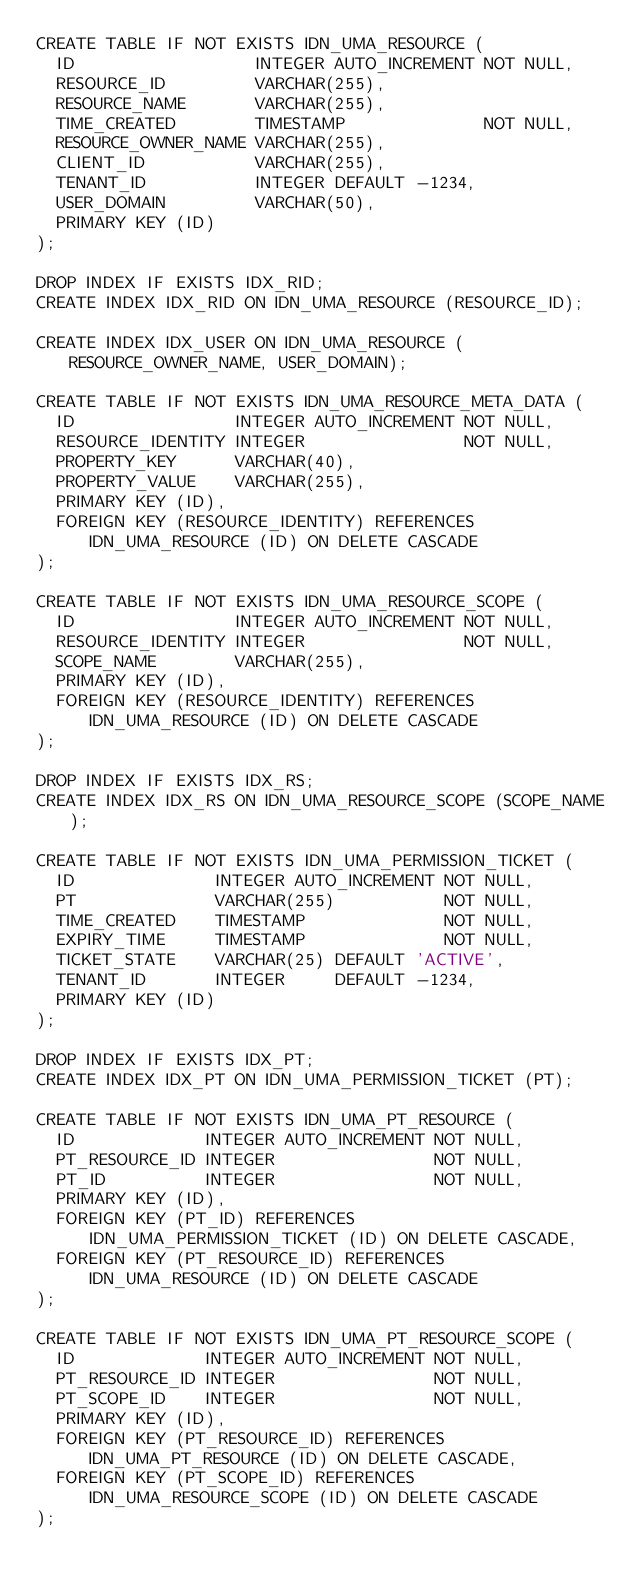<code> <loc_0><loc_0><loc_500><loc_500><_SQL_>CREATE TABLE IF NOT EXISTS IDN_UMA_RESOURCE (
  ID                  INTEGER AUTO_INCREMENT NOT NULL,
  RESOURCE_ID         VARCHAR(255),
  RESOURCE_NAME       VARCHAR(255),
  TIME_CREATED        TIMESTAMP              NOT NULL,
  RESOURCE_OWNER_NAME VARCHAR(255),
  CLIENT_ID           VARCHAR(255),
  TENANT_ID           INTEGER DEFAULT -1234,
  USER_DOMAIN         VARCHAR(50),
  PRIMARY KEY (ID)
);

DROP INDEX IF EXISTS IDX_RID;
CREATE INDEX IDX_RID ON IDN_UMA_RESOURCE (RESOURCE_ID);

CREATE INDEX IDX_USER ON IDN_UMA_RESOURCE (RESOURCE_OWNER_NAME, USER_DOMAIN);

CREATE TABLE IF NOT EXISTS IDN_UMA_RESOURCE_META_DATA (
  ID                INTEGER AUTO_INCREMENT NOT NULL,
  RESOURCE_IDENTITY INTEGER                NOT NULL,
  PROPERTY_KEY      VARCHAR(40),
  PROPERTY_VALUE    VARCHAR(255),
  PRIMARY KEY (ID),
  FOREIGN KEY (RESOURCE_IDENTITY) REFERENCES IDN_UMA_RESOURCE (ID) ON DELETE CASCADE
);

CREATE TABLE IF NOT EXISTS IDN_UMA_RESOURCE_SCOPE (
  ID                INTEGER AUTO_INCREMENT NOT NULL,
  RESOURCE_IDENTITY INTEGER                NOT NULL,
  SCOPE_NAME        VARCHAR(255),
  PRIMARY KEY (ID),
  FOREIGN KEY (RESOURCE_IDENTITY) REFERENCES IDN_UMA_RESOURCE (ID) ON DELETE CASCADE
);

DROP INDEX IF EXISTS IDX_RS;
CREATE INDEX IDX_RS ON IDN_UMA_RESOURCE_SCOPE (SCOPE_NAME);

CREATE TABLE IF NOT EXISTS IDN_UMA_PERMISSION_TICKET (
  ID              INTEGER AUTO_INCREMENT NOT NULL,
  PT              VARCHAR(255)           NOT NULL,
  TIME_CREATED    TIMESTAMP              NOT NULL,
  EXPIRY_TIME     TIMESTAMP              NOT NULL,
  TICKET_STATE    VARCHAR(25) DEFAULT 'ACTIVE',
  TENANT_ID       INTEGER     DEFAULT -1234,
  PRIMARY KEY (ID)
);

DROP INDEX IF EXISTS IDX_PT;
CREATE INDEX IDX_PT ON IDN_UMA_PERMISSION_TICKET (PT);

CREATE TABLE IF NOT EXISTS IDN_UMA_PT_RESOURCE (
  ID             INTEGER AUTO_INCREMENT NOT NULL,
  PT_RESOURCE_ID INTEGER                NOT NULL,
  PT_ID          INTEGER                NOT NULL,
  PRIMARY KEY (ID),
  FOREIGN KEY (PT_ID) REFERENCES IDN_UMA_PERMISSION_TICKET (ID) ON DELETE CASCADE,
  FOREIGN KEY (PT_RESOURCE_ID) REFERENCES IDN_UMA_RESOURCE (ID) ON DELETE CASCADE
);

CREATE TABLE IF NOT EXISTS IDN_UMA_PT_RESOURCE_SCOPE (
  ID             INTEGER AUTO_INCREMENT NOT NULL,
  PT_RESOURCE_ID INTEGER                NOT NULL,
  PT_SCOPE_ID    INTEGER                NOT NULL,
  PRIMARY KEY (ID),
  FOREIGN KEY (PT_RESOURCE_ID) REFERENCES IDN_UMA_PT_RESOURCE (ID) ON DELETE CASCADE,
  FOREIGN KEY (PT_SCOPE_ID) REFERENCES IDN_UMA_RESOURCE_SCOPE (ID) ON DELETE CASCADE
);
</code> 